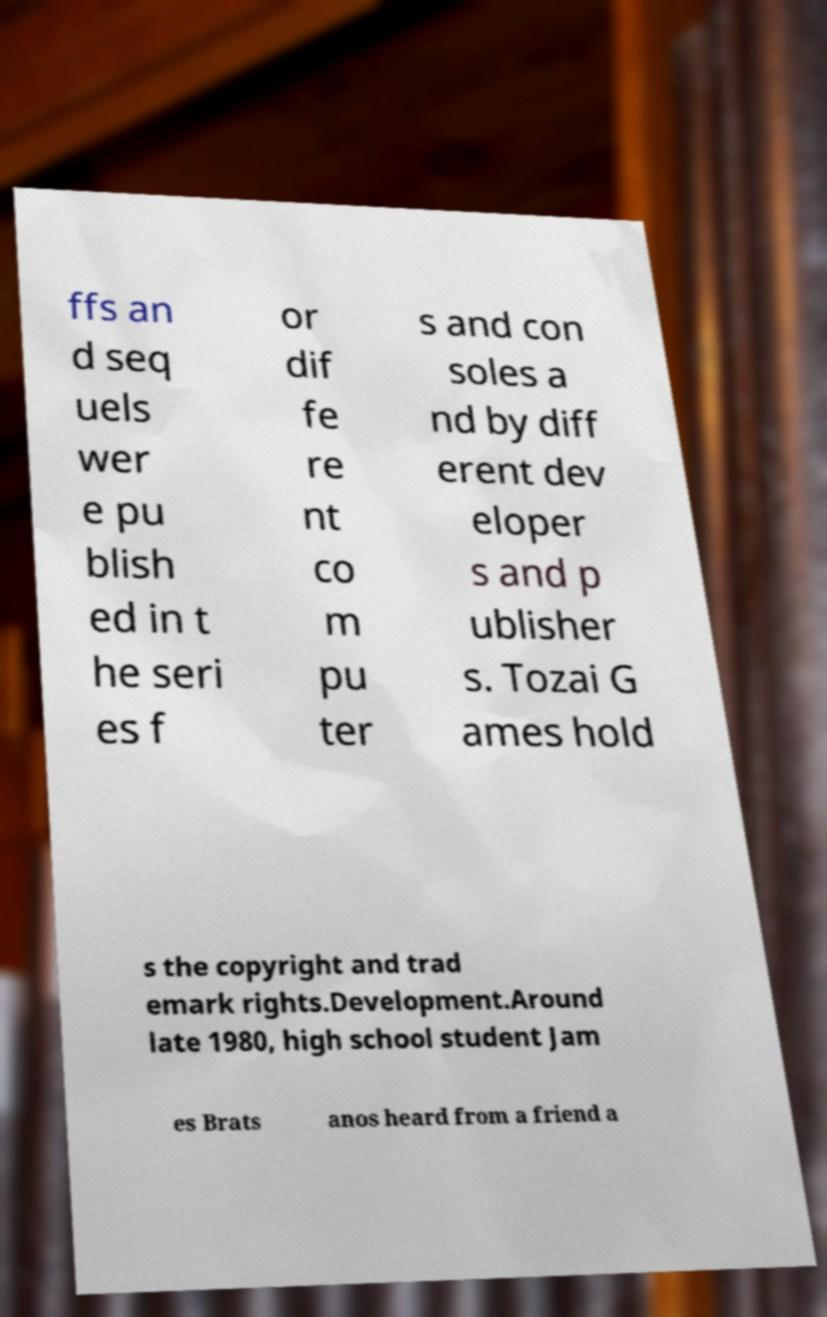Can you read and provide the text displayed in the image?This photo seems to have some interesting text. Can you extract and type it out for me? ffs an d seq uels wer e pu blish ed in t he seri es f or dif fe re nt co m pu ter s and con soles a nd by diff erent dev eloper s and p ublisher s. Tozai G ames hold s the copyright and trad emark rights.Development.Around late 1980, high school student Jam es Brats anos heard from a friend a 